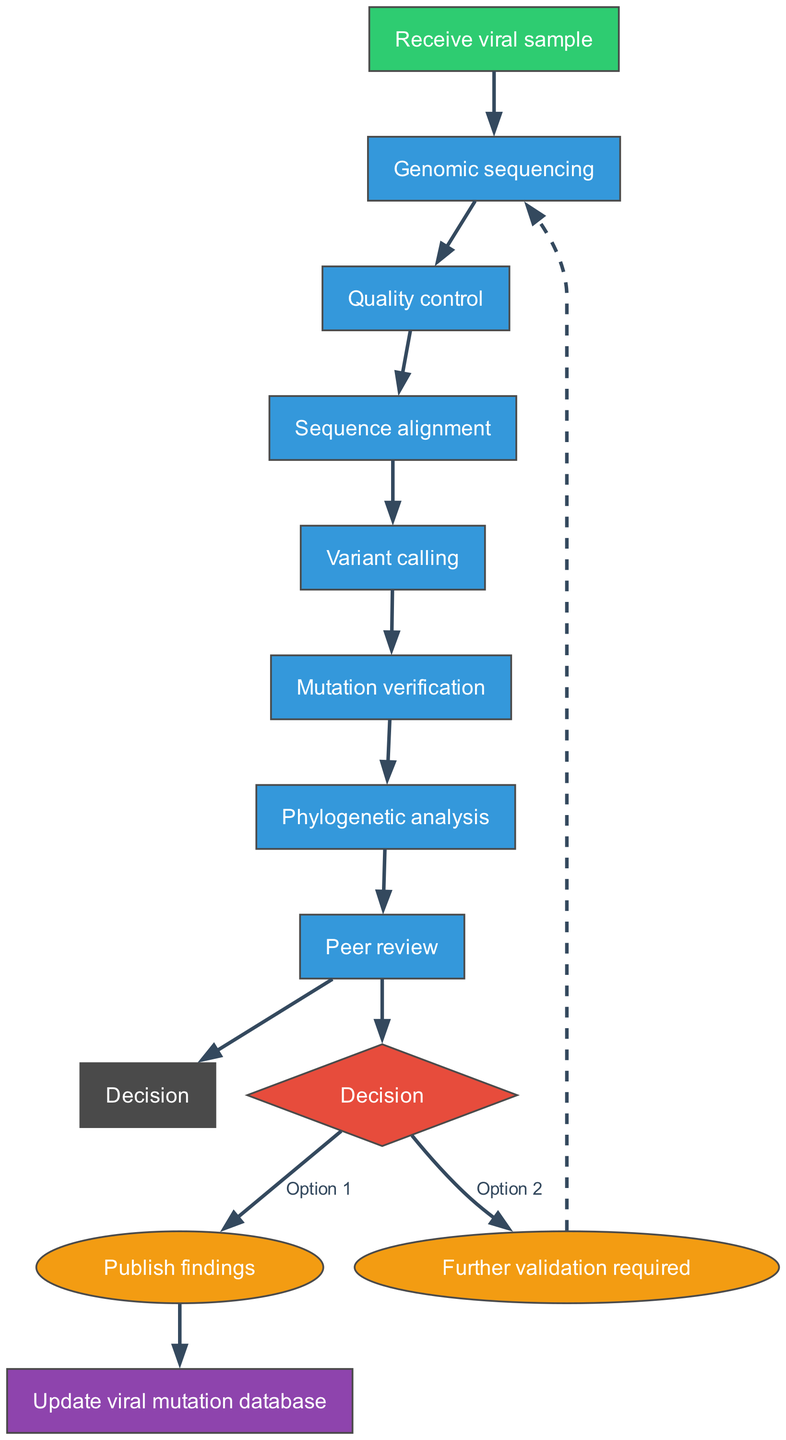What is the first step in the workflow? The diagram indicates that the first step is "Receive viral sample," which is explicitly listed as the starting node.
Answer: Receive viral sample How many processes are there in the workflow? By counting the nodes in the "process" section, we find there are six individual processes listed: genomic sequencing, quality control, sequence alignment, variant calling, mutation verification, and phylogenetic analysis.
Answer: Six What connects "phylogenetic analysis" to "peer review"? The diagram shows that there is a direct edge connecting the "phylogenetic analysis" node to the "peer review" node, indicating that peer review follows phylogenetic analysis.
Answer: Edge What action follows the decision "Publish findings"? The diagram indicates that if the "Publish findings" decision is chosen, it leads directly to the "Update viral mutation database," marking the final step in the workflow.
Answer: Update viral mutation database If "Further validation required" is chosen, where does the workflow lead next? The diagram shows that selecting "Further validation required" leads back to the first process, "Genomic sequencing," creating a loop for additional validation after the decision.
Answer: Genomic sequencing How many options are available in the decision phase? The diagram clearly shows two options at the decision node: "Publish findings" and "Further validation required," meaning there are a total of two choices.
Answer: Two What color represents the quality control process? In the diagram, the quality control process node is filled with a blue color, which is indicated by the defined color for process nodes.
Answer: Blue What is the shape of the decision node? The diagram indicates that the decision node takes the shape of a diamond, which is a common representation for decision points in flowcharts.
Answer: Diamond Which process comes immediately before "mutation verification"? By examining the flow from the processes, we can see that "variant calling" directly precedes "mutation verification" in the sequence of the diagram.
Answer: Variant calling 